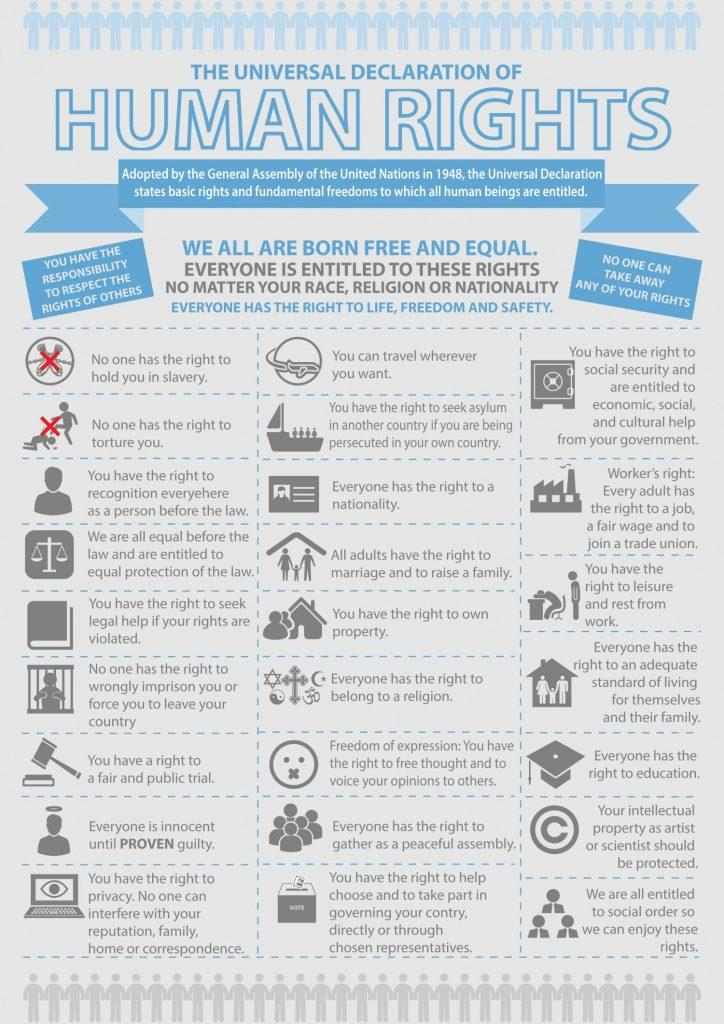Point out several critical features in this image. The Universal Declaration of Human Rights has been adopted by the United Nations and includes 25 human rights. 